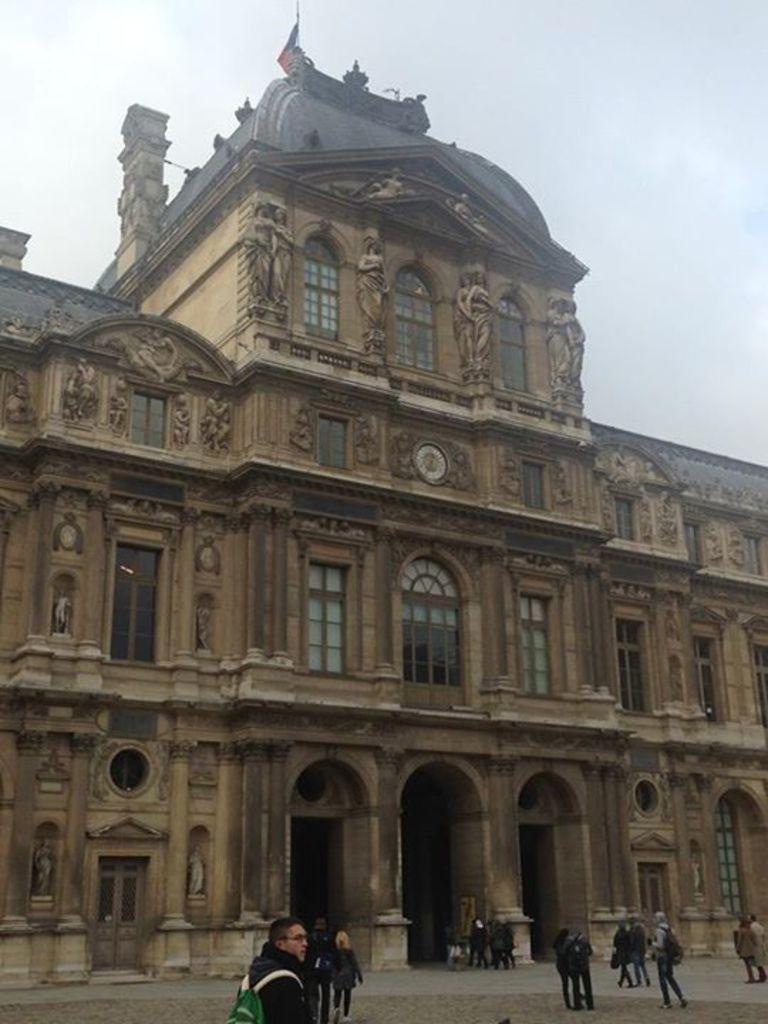Can you describe this image briefly? Here, we can see some people standing on the floor, we can see a building and there are some windows on the building, at the top there is a sky which is cloudy. 